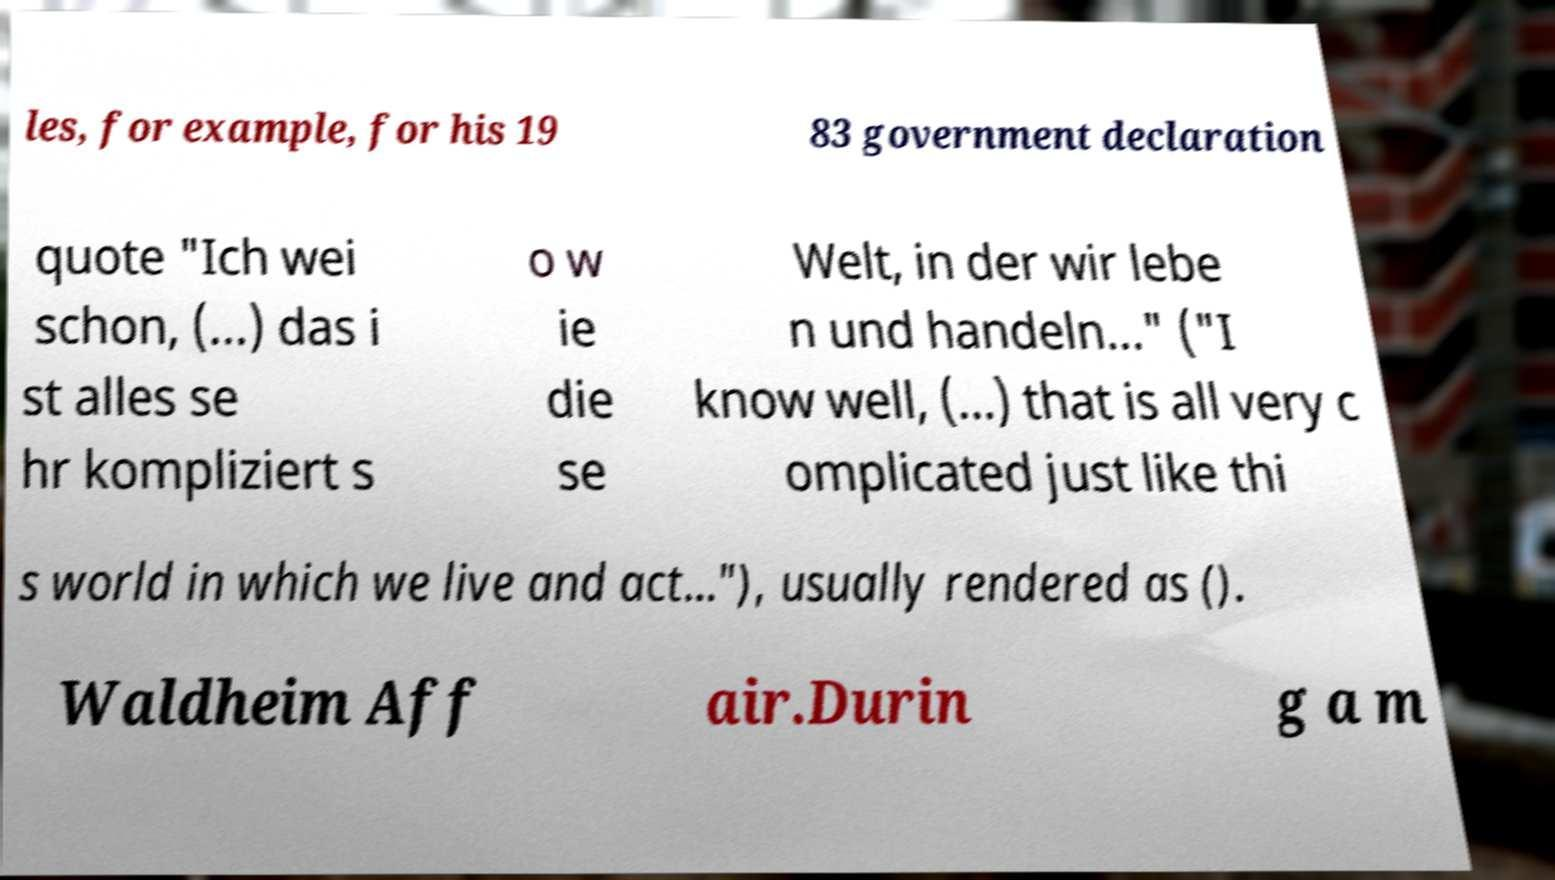There's text embedded in this image that I need extracted. Can you transcribe it verbatim? les, for example, for his 19 83 government declaration quote "Ich wei schon, (...) das i st alles se hr kompliziert s o w ie die se Welt, in der wir lebe n und handeln..." ("I know well, (...) that is all very c omplicated just like thi s world in which we live and act..."), usually rendered as (). Waldheim Aff air.Durin g a m 